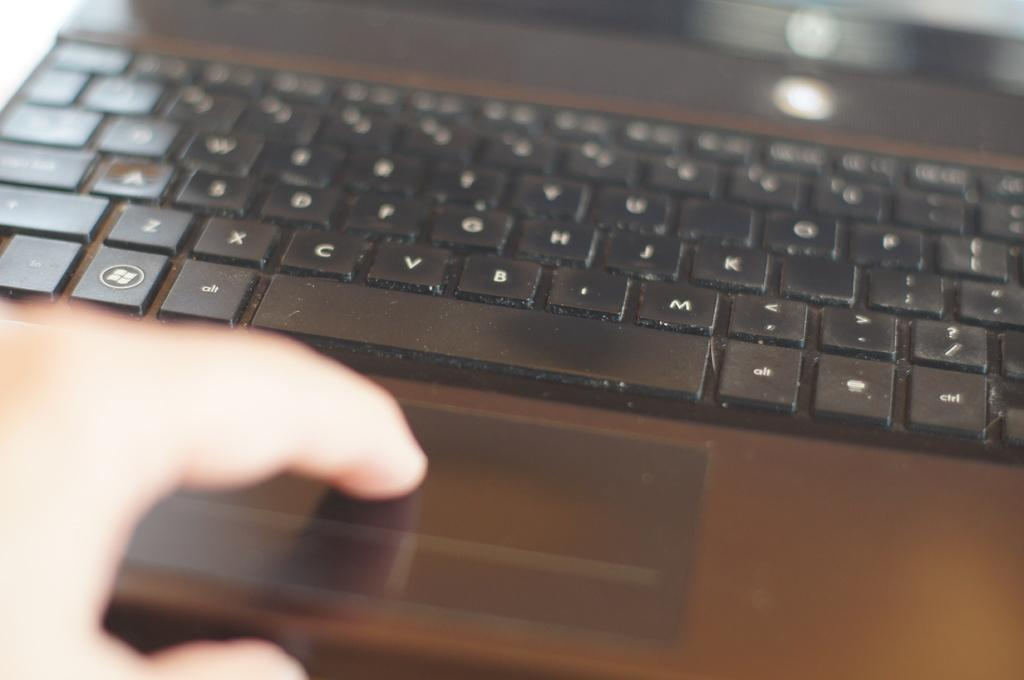<image>
Create a compact narrative representing the image presented. A black keyboard shows the ALT key is next to the space bar. 